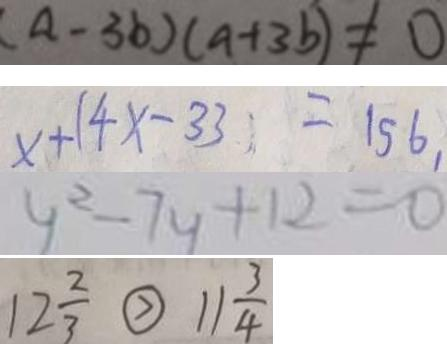<formula> <loc_0><loc_0><loc_500><loc_500>( a - 3 b ) ( a + 3 b ) \neq 0 
 x + 1 4 x - 3 3 = 1 5 6 , 
 y ^ { 2 } - 7 y + 1 2 = 0 
 1 2 \frac { 2 } { 3 } \textcircled { > } 1 1 \frac { 3 } { 4 }</formula> 